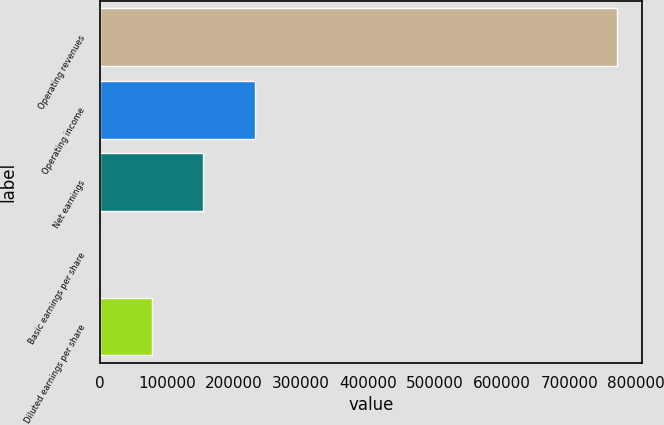Convert chart to OTSL. <chart><loc_0><loc_0><loc_500><loc_500><bar_chart><fcel>Operating revenues<fcel>Operating income<fcel>Net earnings<fcel>Basic earnings per share<fcel>Diluted earnings per share<nl><fcel>770805<fcel>231242<fcel>154161<fcel>0.24<fcel>77080.7<nl></chart> 